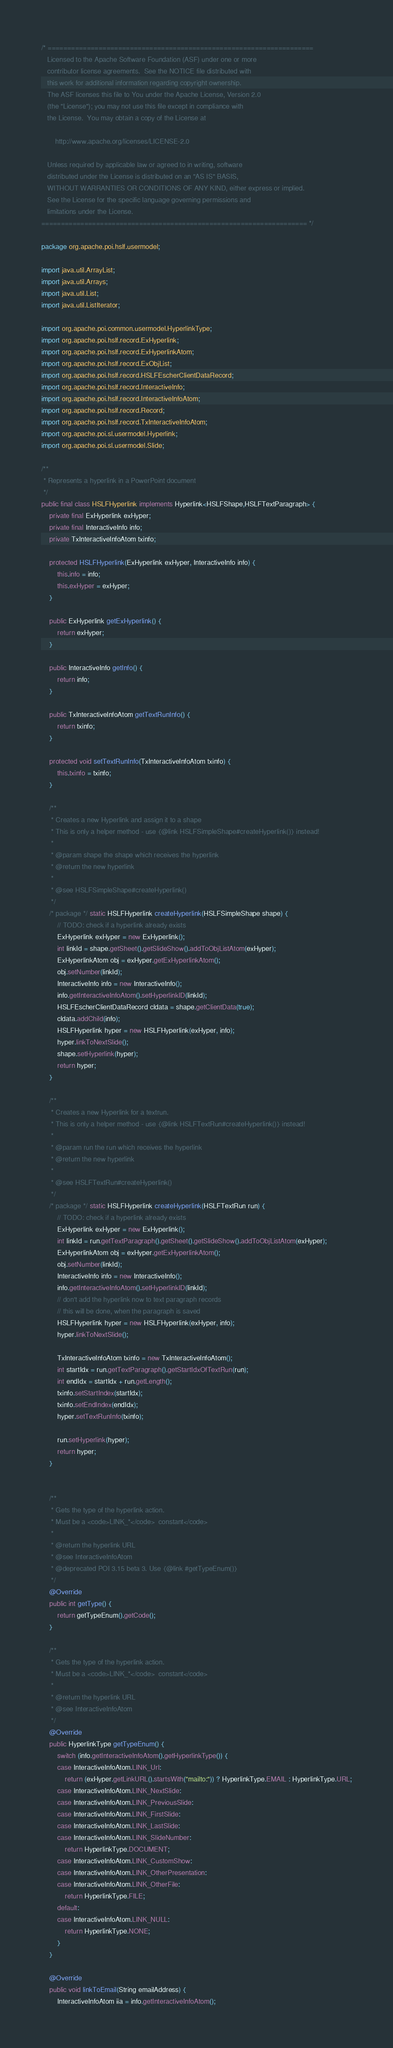Convert code to text. <code><loc_0><loc_0><loc_500><loc_500><_Java_>/* ====================================================================
   Licensed to the Apache Software Foundation (ASF) under one or more
   contributor license agreements.  See the NOTICE file distributed with
   this work for additional information regarding copyright ownership.
   The ASF licenses this file to You under the Apache License, Version 2.0
   (the "License"); you may not use this file except in compliance with
   the License.  You may obtain a copy of the License at

       http://www.apache.org/licenses/LICENSE-2.0

   Unless required by applicable law or agreed to in writing, software
   distributed under the License is distributed on an "AS IS" BASIS,
   WITHOUT WARRANTIES OR CONDITIONS OF ANY KIND, either express or implied.
   See the License for the specific language governing permissions and
   limitations under the License.
==================================================================== */

package org.apache.poi.hslf.usermodel;

import java.util.ArrayList;
import java.util.Arrays;
import java.util.List;
import java.util.ListIterator;

import org.apache.poi.common.usermodel.HyperlinkType;
import org.apache.poi.hslf.record.ExHyperlink;
import org.apache.poi.hslf.record.ExHyperlinkAtom;
import org.apache.poi.hslf.record.ExObjList;
import org.apache.poi.hslf.record.HSLFEscherClientDataRecord;
import org.apache.poi.hslf.record.InteractiveInfo;
import org.apache.poi.hslf.record.InteractiveInfoAtom;
import org.apache.poi.hslf.record.Record;
import org.apache.poi.hslf.record.TxInteractiveInfoAtom;
import org.apache.poi.sl.usermodel.Hyperlink;
import org.apache.poi.sl.usermodel.Slide;

/**
 * Represents a hyperlink in a PowerPoint document
 */
public final class HSLFHyperlink implements Hyperlink<HSLFShape,HSLFTextParagraph> {
    private final ExHyperlink exHyper;
    private final InteractiveInfo info;
    private TxInteractiveInfoAtom txinfo;

    protected HSLFHyperlink(ExHyperlink exHyper, InteractiveInfo info) {
        this.info = info;
        this.exHyper = exHyper;
    }

    public ExHyperlink getExHyperlink() {
        return exHyper;
    }
    
    public InteractiveInfo getInfo() {
        return info;
    }
    
    public TxInteractiveInfoAtom getTextRunInfo() {
        return txinfo;
    }
    
    protected void setTextRunInfo(TxInteractiveInfoAtom txinfo) {
        this.txinfo = txinfo;
    }

    /**
     * Creates a new Hyperlink and assign it to a shape
     * This is only a helper method - use {@link HSLFSimpleShape#createHyperlink()} instead!
     *
     * @param shape the shape which receives the hyperlink
     * @return the new hyperlink
     * 
     * @see HSLFSimpleShape#createHyperlink()
     */
    /* package */ static HSLFHyperlink createHyperlink(HSLFSimpleShape shape) {
        // TODO: check if a hyperlink already exists
        ExHyperlink exHyper = new ExHyperlink();
        int linkId = shape.getSheet().getSlideShow().addToObjListAtom(exHyper);
        ExHyperlinkAtom obj = exHyper.getExHyperlinkAtom();
        obj.setNumber(linkId);
        InteractiveInfo info = new InteractiveInfo();
        info.getInteractiveInfoAtom().setHyperlinkID(linkId);
        HSLFEscherClientDataRecord cldata = shape.getClientData(true);
        cldata.addChild(info);
        HSLFHyperlink hyper = new HSLFHyperlink(exHyper, info);
        hyper.linkToNextSlide();
        shape.setHyperlink(hyper);
        return hyper;
    }

    /**
     * Creates a new Hyperlink for a textrun.
     * This is only a helper method - use {@link HSLFTextRun#createHyperlink()} instead!
     *
     * @param run the run which receives the hyperlink
     * @return the new hyperlink
     * 
     * @see HSLFTextRun#createHyperlink()
     */
    /* package */ static HSLFHyperlink createHyperlink(HSLFTextRun run) {
        // TODO: check if a hyperlink already exists
        ExHyperlink exHyper = new ExHyperlink();
        int linkId = run.getTextParagraph().getSheet().getSlideShow().addToObjListAtom(exHyper);
        ExHyperlinkAtom obj = exHyper.getExHyperlinkAtom();
        obj.setNumber(linkId);
        InteractiveInfo info = new InteractiveInfo();
        info.getInteractiveInfoAtom().setHyperlinkID(linkId);
        // don't add the hyperlink now to text paragraph records
        // this will be done, when the paragraph is saved
        HSLFHyperlink hyper = new HSLFHyperlink(exHyper, info);
        hyper.linkToNextSlide();
        
        TxInteractiveInfoAtom txinfo = new TxInteractiveInfoAtom();
        int startIdx = run.getTextParagraph().getStartIdxOfTextRun(run);
        int endIdx = startIdx + run.getLength();
        txinfo.setStartIndex(startIdx);
        txinfo.setEndIndex(endIdx);
        hyper.setTextRunInfo(txinfo);
        
        run.setHyperlink(hyper);
        return hyper;
    }
    

    /**
     * Gets the type of the hyperlink action.
     * Must be a <code>LINK_*</code>  constant</code>
     *
     * @return the hyperlink URL
     * @see InteractiveInfoAtom
     * @deprecated POI 3.15 beta 3. Use {@link #getTypeEnum()}
     */
    @Override
    public int getType() {
        return getTypeEnum().getCode();
    }
    
    /**
     * Gets the type of the hyperlink action.
     * Must be a <code>LINK_*</code>  constant</code>
     *
     * @return the hyperlink URL
     * @see InteractiveInfoAtom
     */
    @Override
    public HyperlinkType getTypeEnum() {
        switch (info.getInteractiveInfoAtom().getHyperlinkType()) {
        case InteractiveInfoAtom.LINK_Url:
            return (exHyper.getLinkURL().startsWith("mailto:")) ? HyperlinkType.EMAIL : HyperlinkType.URL;
        case InteractiveInfoAtom.LINK_NextSlide:
        case InteractiveInfoAtom.LINK_PreviousSlide:
        case InteractiveInfoAtom.LINK_FirstSlide:
        case InteractiveInfoAtom.LINK_LastSlide:
        case InteractiveInfoAtom.LINK_SlideNumber:
            return HyperlinkType.DOCUMENT;
        case InteractiveInfoAtom.LINK_CustomShow:
        case InteractiveInfoAtom.LINK_OtherPresentation:
        case InteractiveInfoAtom.LINK_OtherFile:
            return HyperlinkType.FILE;
        default:
        case InteractiveInfoAtom.LINK_NULL:
            return HyperlinkType.NONE;
        }
    }

    @Override
    public void linkToEmail(String emailAddress) {
        InteractiveInfoAtom iia = info.getInteractiveInfoAtom();</code> 